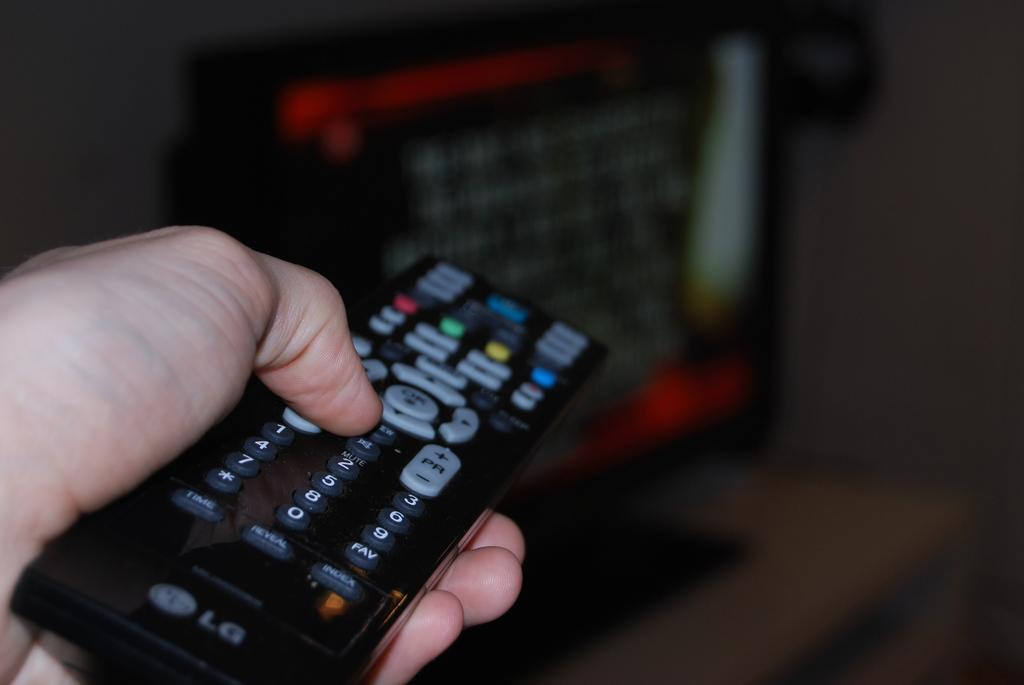<image>
Relay a brief, clear account of the picture shown. Someone is holding an LG branded remote control and pressing the buttons. 